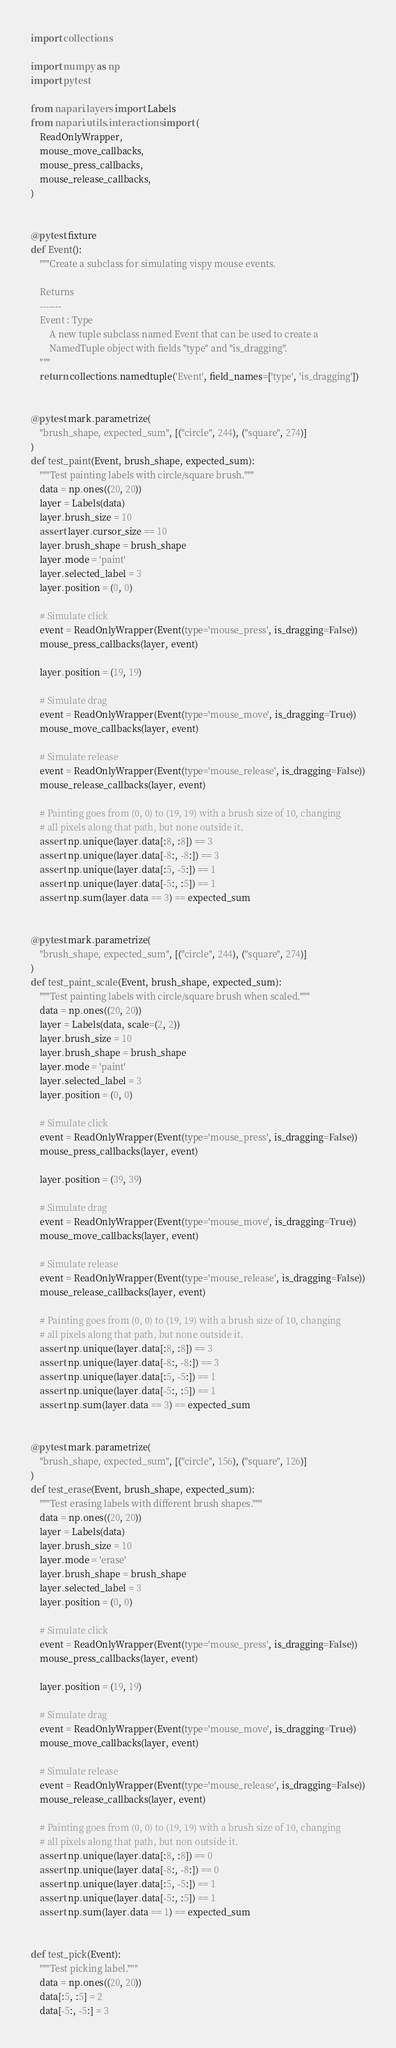<code> <loc_0><loc_0><loc_500><loc_500><_Python_>import collections

import numpy as np
import pytest

from napari.layers import Labels
from napari.utils.interactions import (
    ReadOnlyWrapper,
    mouse_move_callbacks,
    mouse_press_callbacks,
    mouse_release_callbacks,
)


@pytest.fixture
def Event():
    """Create a subclass for simulating vispy mouse events.

    Returns
    -------
    Event : Type
        A new tuple subclass named Event that can be used to create a
        NamedTuple object with fields "type" and "is_dragging".
    """
    return collections.namedtuple('Event', field_names=['type', 'is_dragging'])


@pytest.mark.parametrize(
    "brush_shape, expected_sum", [("circle", 244), ("square", 274)]
)
def test_paint(Event, brush_shape, expected_sum):
    """Test painting labels with circle/square brush."""
    data = np.ones((20, 20))
    layer = Labels(data)
    layer.brush_size = 10
    assert layer.cursor_size == 10
    layer.brush_shape = brush_shape
    layer.mode = 'paint'
    layer.selected_label = 3
    layer.position = (0, 0)

    # Simulate click
    event = ReadOnlyWrapper(Event(type='mouse_press', is_dragging=False))
    mouse_press_callbacks(layer, event)

    layer.position = (19, 19)

    # Simulate drag
    event = ReadOnlyWrapper(Event(type='mouse_move', is_dragging=True))
    mouse_move_callbacks(layer, event)

    # Simulate release
    event = ReadOnlyWrapper(Event(type='mouse_release', is_dragging=False))
    mouse_release_callbacks(layer, event)

    # Painting goes from (0, 0) to (19, 19) with a brush size of 10, changing
    # all pixels along that path, but none outside it.
    assert np.unique(layer.data[:8, :8]) == 3
    assert np.unique(layer.data[-8:, -8:]) == 3
    assert np.unique(layer.data[:5, -5:]) == 1
    assert np.unique(layer.data[-5:, :5]) == 1
    assert np.sum(layer.data == 3) == expected_sum


@pytest.mark.parametrize(
    "brush_shape, expected_sum", [("circle", 244), ("square", 274)]
)
def test_paint_scale(Event, brush_shape, expected_sum):
    """Test painting labels with circle/square brush when scaled."""
    data = np.ones((20, 20))
    layer = Labels(data, scale=(2, 2))
    layer.brush_size = 10
    layer.brush_shape = brush_shape
    layer.mode = 'paint'
    layer.selected_label = 3
    layer.position = (0, 0)

    # Simulate click
    event = ReadOnlyWrapper(Event(type='mouse_press', is_dragging=False))
    mouse_press_callbacks(layer, event)

    layer.position = (39, 39)

    # Simulate drag
    event = ReadOnlyWrapper(Event(type='mouse_move', is_dragging=True))
    mouse_move_callbacks(layer, event)

    # Simulate release
    event = ReadOnlyWrapper(Event(type='mouse_release', is_dragging=False))
    mouse_release_callbacks(layer, event)

    # Painting goes from (0, 0) to (19, 19) with a brush size of 10, changing
    # all pixels along that path, but none outside it.
    assert np.unique(layer.data[:8, :8]) == 3
    assert np.unique(layer.data[-8:, -8:]) == 3
    assert np.unique(layer.data[:5, -5:]) == 1
    assert np.unique(layer.data[-5:, :5]) == 1
    assert np.sum(layer.data == 3) == expected_sum


@pytest.mark.parametrize(
    "brush_shape, expected_sum", [("circle", 156), ("square", 126)]
)
def test_erase(Event, brush_shape, expected_sum):
    """Test erasing labels with different brush shapes."""
    data = np.ones((20, 20))
    layer = Labels(data)
    layer.brush_size = 10
    layer.mode = 'erase'
    layer.brush_shape = brush_shape
    layer.selected_label = 3
    layer.position = (0, 0)

    # Simulate click
    event = ReadOnlyWrapper(Event(type='mouse_press', is_dragging=False))
    mouse_press_callbacks(layer, event)

    layer.position = (19, 19)

    # Simulate drag
    event = ReadOnlyWrapper(Event(type='mouse_move', is_dragging=True))
    mouse_move_callbacks(layer, event)

    # Simulate release
    event = ReadOnlyWrapper(Event(type='mouse_release', is_dragging=False))
    mouse_release_callbacks(layer, event)

    # Painting goes from (0, 0) to (19, 19) with a brush size of 10, changing
    # all pixels along that path, but non outside it.
    assert np.unique(layer.data[:8, :8]) == 0
    assert np.unique(layer.data[-8:, -8:]) == 0
    assert np.unique(layer.data[:5, -5:]) == 1
    assert np.unique(layer.data[-5:, :5]) == 1
    assert np.sum(layer.data == 1) == expected_sum


def test_pick(Event):
    """Test picking label."""
    data = np.ones((20, 20))
    data[:5, :5] = 2
    data[-5:, -5:] = 3</code> 